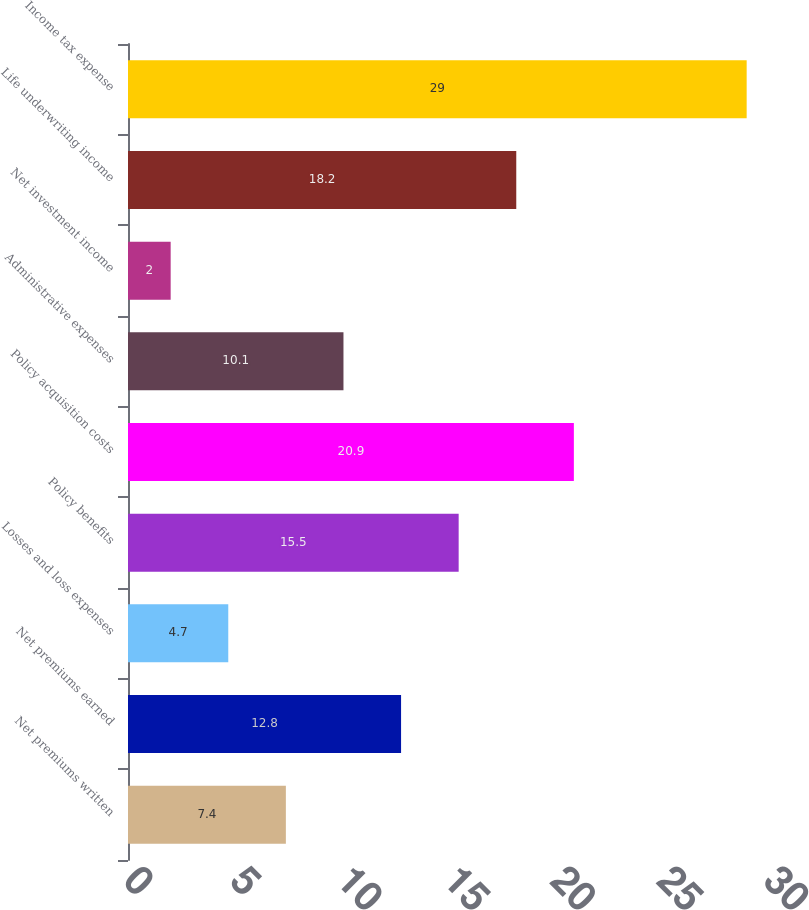Convert chart. <chart><loc_0><loc_0><loc_500><loc_500><bar_chart><fcel>Net premiums written<fcel>Net premiums earned<fcel>Losses and loss expenses<fcel>Policy benefits<fcel>Policy acquisition costs<fcel>Administrative expenses<fcel>Net investment income<fcel>Life underwriting income<fcel>Income tax expense<nl><fcel>7.4<fcel>12.8<fcel>4.7<fcel>15.5<fcel>20.9<fcel>10.1<fcel>2<fcel>18.2<fcel>29<nl></chart> 